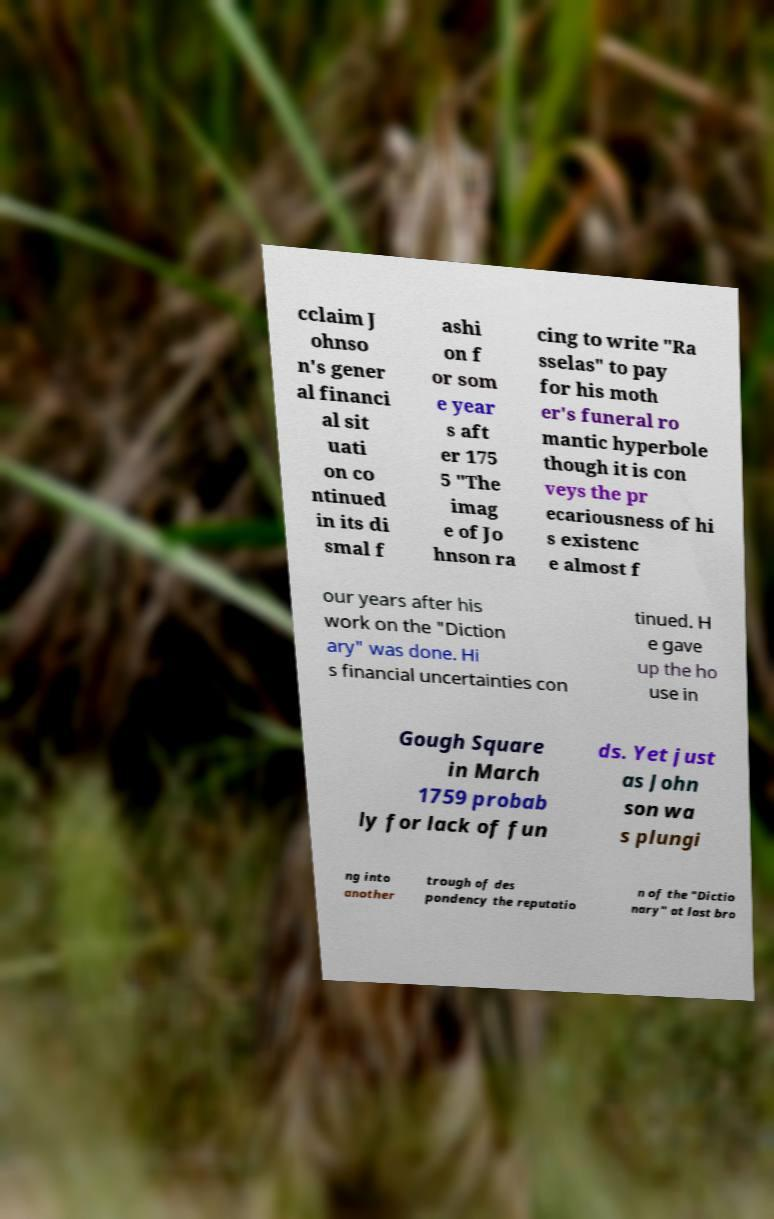For documentation purposes, I need the text within this image transcribed. Could you provide that? cclaim J ohnso n's gener al financi al sit uati on co ntinued in its di smal f ashi on f or som e year s aft er 175 5 "The imag e of Jo hnson ra cing to write "Ra sselas" to pay for his moth er's funeral ro mantic hyperbole though it is con veys the pr ecariousness of hi s existenc e almost f our years after his work on the "Diction ary" was done. Hi s financial uncertainties con tinued. H e gave up the ho use in Gough Square in March 1759 probab ly for lack of fun ds. Yet just as John son wa s plungi ng into another trough of des pondency the reputatio n of the "Dictio nary" at last bro 